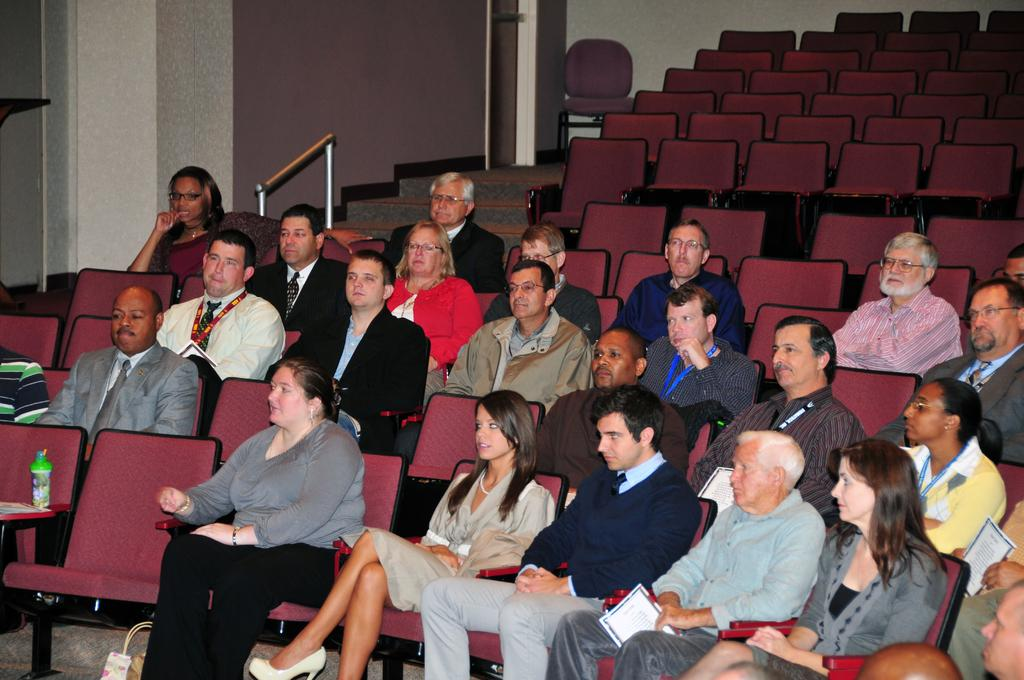What are the people in the image doing? The people in the image are sitting on chairs in the center of the image. What can be seen in the background of the image? There is a wall and a staircase in the background of the image. How many quince are being held by the people in the image? There are no quince present in the image. What level of expertise do the people sitting on chairs have in the image? The image does not provide information about the people's expertise or skill level. 